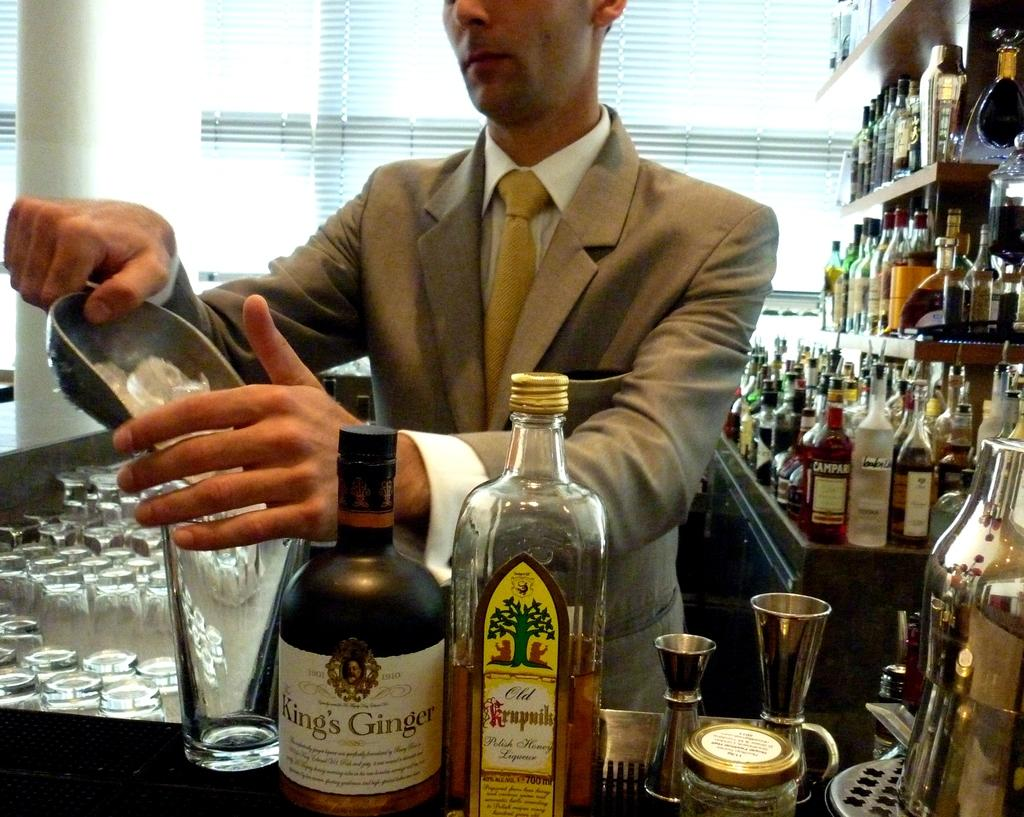Provide a one-sentence caption for the provided image. A bartender is making a drink next to a bottle of King's Ginger. 